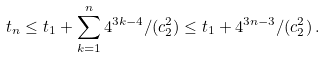<formula> <loc_0><loc_0><loc_500><loc_500>t _ { n } \leq t _ { 1 } + \sum _ { k = 1 } ^ { n } 4 ^ { 3 k - 4 } / ( c ^ { 2 } _ { 2 } ) \leq t _ { 1 } + 4 ^ { 3 n - 3 } / ( c ^ { 2 } _ { 2 } ) \, .</formula> 